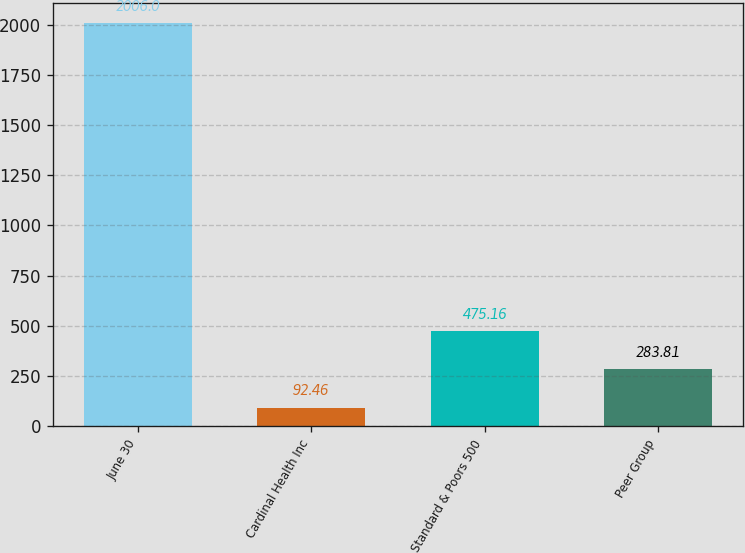<chart> <loc_0><loc_0><loc_500><loc_500><bar_chart><fcel>June 30<fcel>Cardinal Health Inc<fcel>Standard & Poors 500<fcel>Peer Group<nl><fcel>2006<fcel>92.46<fcel>475.16<fcel>283.81<nl></chart> 